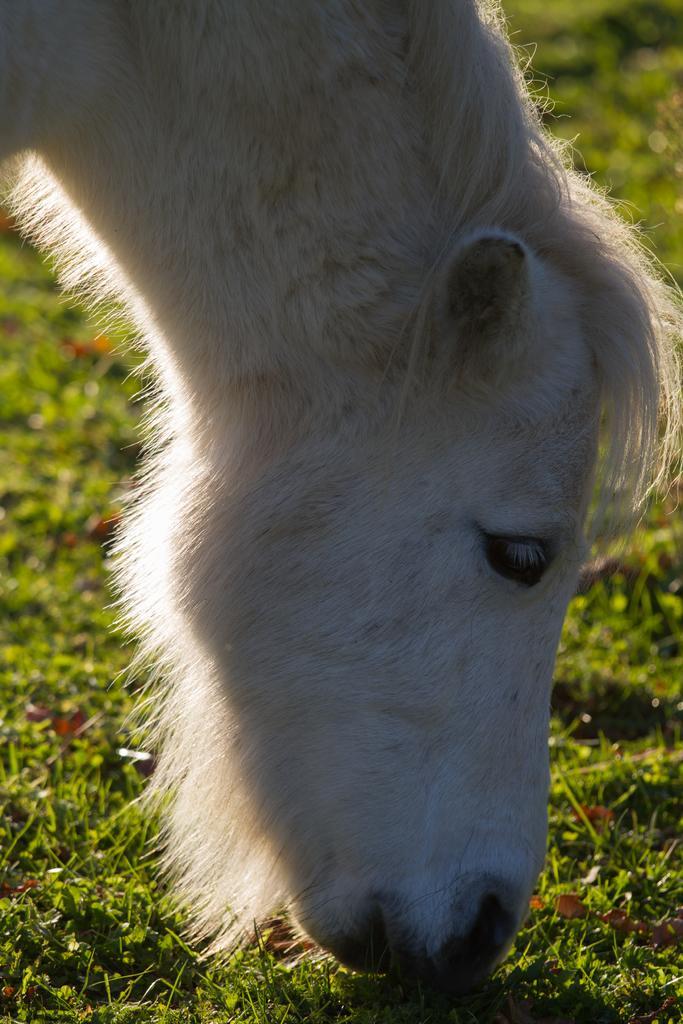Describe this image in one or two sentences. In this image I can see an animal which is white in color. I can see some grass on the ground. 